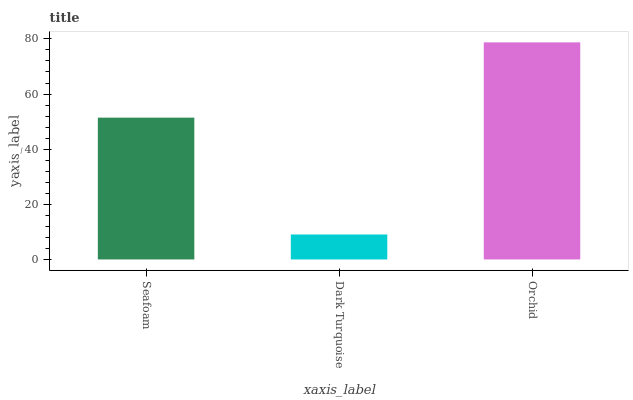Is Dark Turquoise the minimum?
Answer yes or no. Yes. Is Orchid the maximum?
Answer yes or no. Yes. Is Orchid the minimum?
Answer yes or no. No. Is Dark Turquoise the maximum?
Answer yes or no. No. Is Orchid greater than Dark Turquoise?
Answer yes or no. Yes. Is Dark Turquoise less than Orchid?
Answer yes or no. Yes. Is Dark Turquoise greater than Orchid?
Answer yes or no. No. Is Orchid less than Dark Turquoise?
Answer yes or no. No. Is Seafoam the high median?
Answer yes or no. Yes. Is Seafoam the low median?
Answer yes or no. Yes. Is Dark Turquoise the high median?
Answer yes or no. No. Is Orchid the low median?
Answer yes or no. No. 